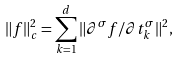Convert formula to latex. <formula><loc_0><loc_0><loc_500><loc_500>\| f \| _ { c } ^ { 2 } = \sum _ { k = 1 } ^ { d } \| \partial ^ { \sigma } f / \partial t _ { k } ^ { \sigma } \| ^ { 2 } ,</formula> 